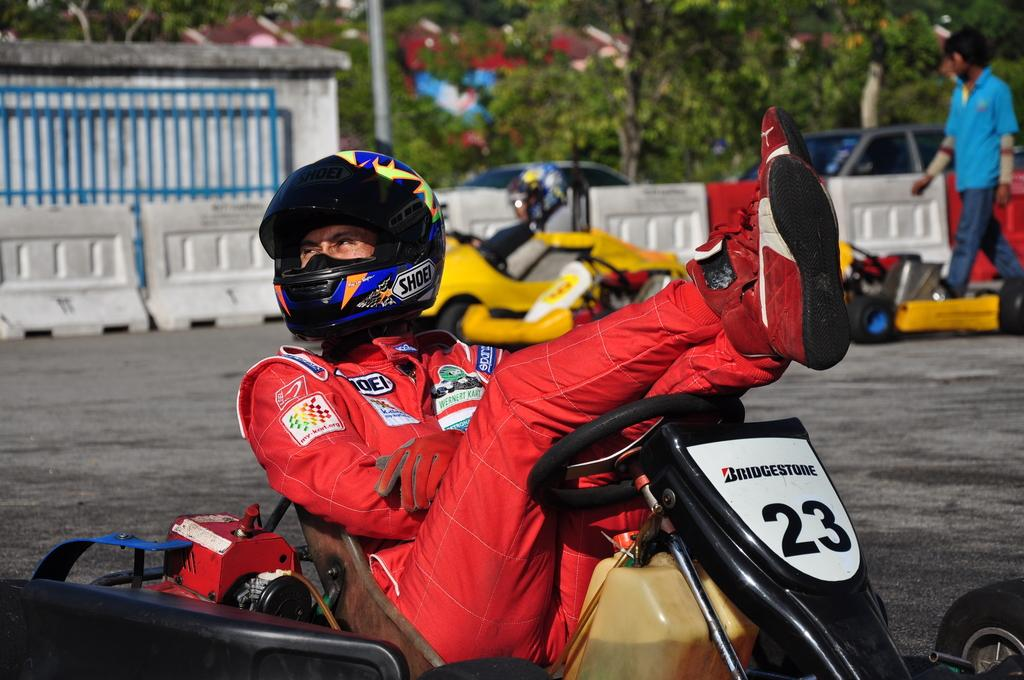What type of vehicles are in the image? There are carrying cars in the image. Who is inside the cars? People are sitting in the cars. What can be seen in the background of the image? There is a railing, trees, and cars visible in the background of the image. How would you describe the appearance of the background? The background appears blurred. What type of apple is being used as a badge in the image? There is no apple or badge present in the image. Is there a prison visible in the image? There is no prison present in the image. 